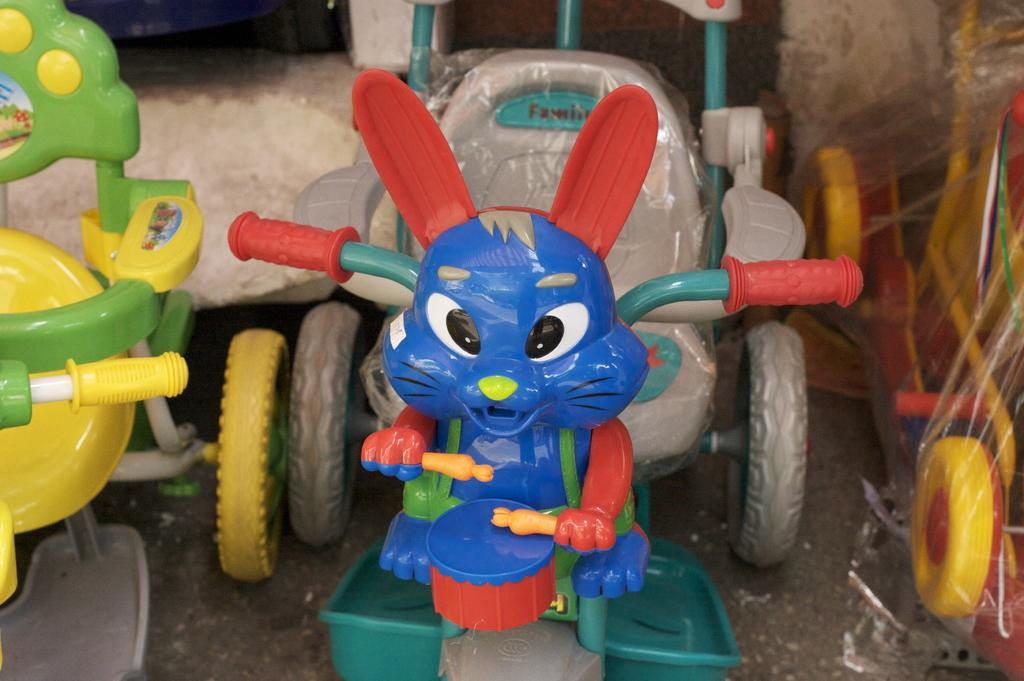What type of toy is in the image? There is a toy bicycle in the image. What colors can be seen on the toy bicycle? The toy bicycle is blue, grey, green, and red in color. Where is the toy bicycle located in the image? The toy bicycle is on the ground. Are there any other bicycles in the image? Yes, there are other bicycles beside the toy bicycle. What colors are the other bicycles? The other bicycles are yellow, green, and red in color. What type of government is depicted in the image? There is no depiction of a government in the image; it features toy bicycles. How old is the person celebrating their birthday in the image? There is no indication of a birthday celebration in the image; it features toy bicycles. 